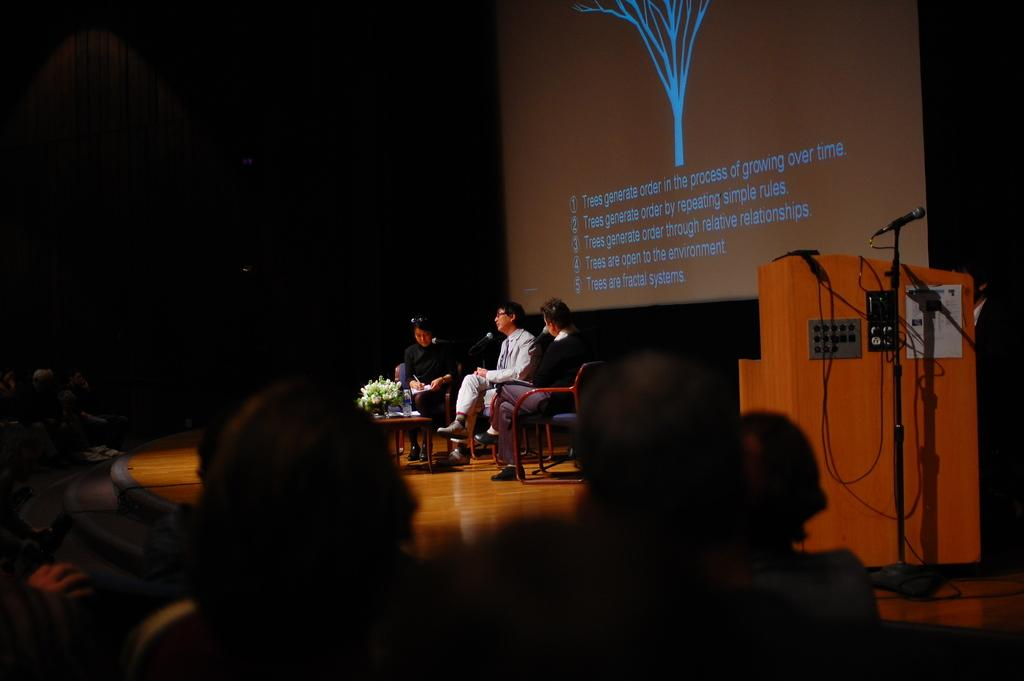What are the people on the stage doing? The people on the stage are sitting. What is located behind the stage? There is a screen on a board behind the stage. Who can be seen in front of the stage? There are people in front of the stage. What type of stick is being used to draw on the screen in the image? There is no stick or drawing on the screen in the image. How much income can be seen on the stage in the image? There is no mention of income in the image. 